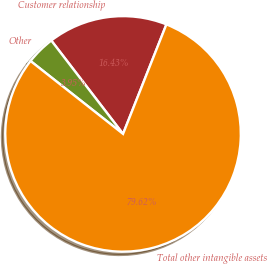Convert chart. <chart><loc_0><loc_0><loc_500><loc_500><pie_chart><fcel>Customer relationship<fcel>Other<fcel>Total other intangible assets<nl><fcel>16.43%<fcel>3.95%<fcel>79.61%<nl></chart> 